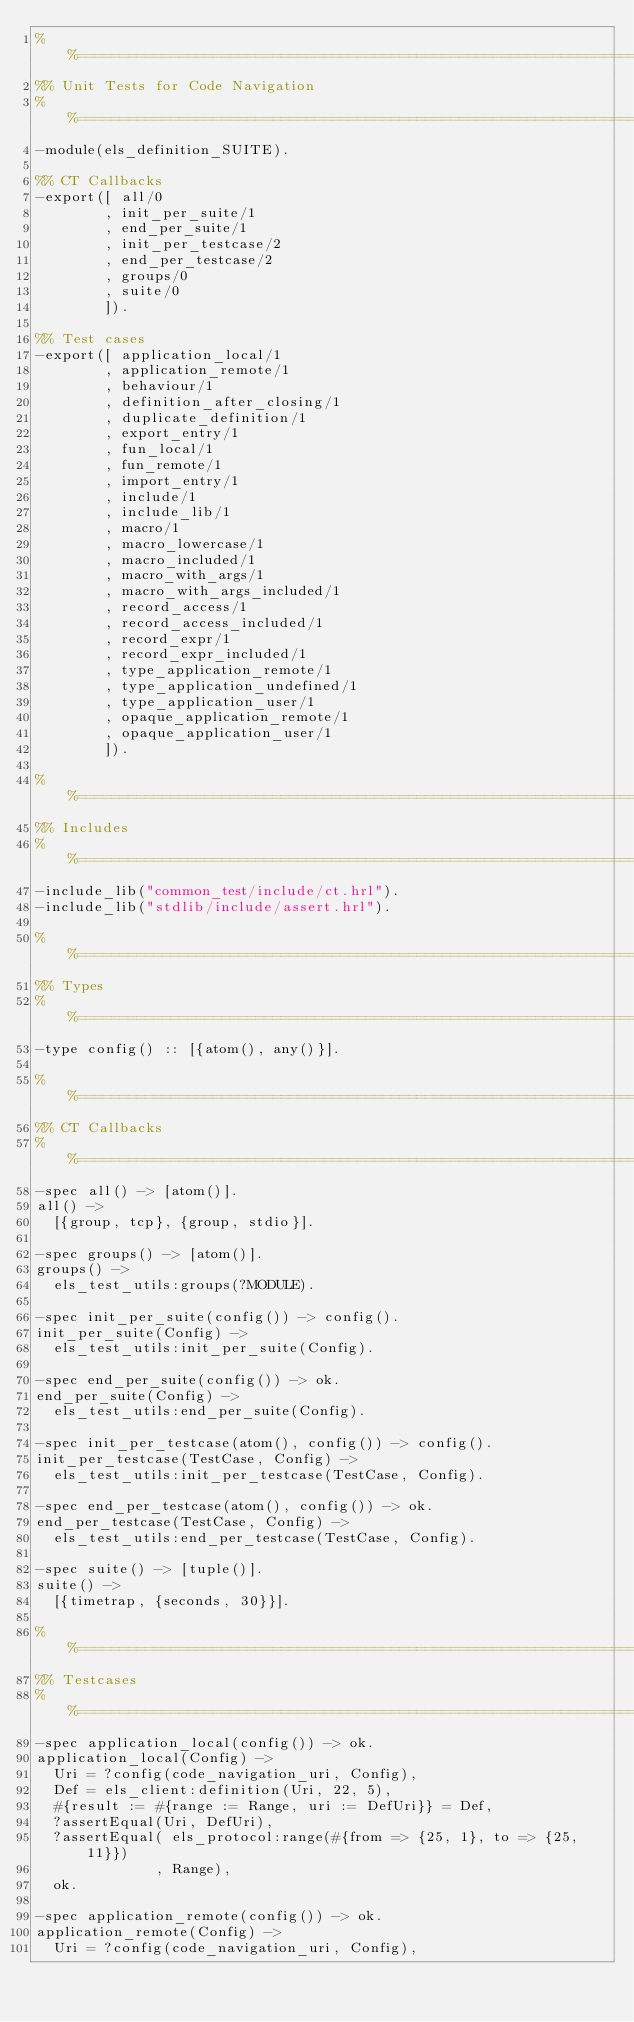Convert code to text. <code><loc_0><loc_0><loc_500><loc_500><_Erlang_>%%==============================================================================
%% Unit Tests for Code Navigation
%%==============================================================================
-module(els_definition_SUITE).

%% CT Callbacks
-export([ all/0
        , init_per_suite/1
        , end_per_suite/1
        , init_per_testcase/2
        , end_per_testcase/2
        , groups/0
        , suite/0
        ]).

%% Test cases
-export([ application_local/1
        , application_remote/1
        , behaviour/1
        , definition_after_closing/1
        , duplicate_definition/1
        , export_entry/1
        , fun_local/1
        , fun_remote/1
        , import_entry/1
        , include/1
        , include_lib/1
        , macro/1
        , macro_lowercase/1
        , macro_included/1
        , macro_with_args/1
        , macro_with_args_included/1
        , record_access/1
        , record_access_included/1
        , record_expr/1
        , record_expr_included/1
        , type_application_remote/1
        , type_application_undefined/1
        , type_application_user/1
        , opaque_application_remote/1
        , opaque_application_user/1
        ]).

%%==============================================================================
%% Includes
%%==============================================================================
-include_lib("common_test/include/ct.hrl").
-include_lib("stdlib/include/assert.hrl").

%%==============================================================================
%% Types
%%==============================================================================
-type config() :: [{atom(), any()}].

%%==============================================================================
%% CT Callbacks
%%==============================================================================
-spec all() -> [atom()].
all() ->
  [{group, tcp}, {group, stdio}].

-spec groups() -> [atom()].
groups() ->
  els_test_utils:groups(?MODULE).

-spec init_per_suite(config()) -> config().
init_per_suite(Config) ->
  els_test_utils:init_per_suite(Config).

-spec end_per_suite(config()) -> ok.
end_per_suite(Config) ->
  els_test_utils:end_per_suite(Config).

-spec init_per_testcase(atom(), config()) -> config().
init_per_testcase(TestCase, Config) ->
  els_test_utils:init_per_testcase(TestCase, Config).

-spec end_per_testcase(atom(), config()) -> ok.
end_per_testcase(TestCase, Config) ->
  els_test_utils:end_per_testcase(TestCase, Config).

-spec suite() -> [tuple()].
suite() ->
  [{timetrap, {seconds, 30}}].

%%==============================================================================
%% Testcases
%%==============================================================================
-spec application_local(config()) -> ok.
application_local(Config) ->
  Uri = ?config(code_navigation_uri, Config),
  Def = els_client:definition(Uri, 22, 5),
  #{result := #{range := Range, uri := DefUri}} = Def,
  ?assertEqual(Uri, DefUri),
  ?assertEqual( els_protocol:range(#{from => {25, 1}, to => {25, 11}})
              , Range),
  ok.

-spec application_remote(config()) -> ok.
application_remote(Config) ->
  Uri = ?config(code_navigation_uri, Config),</code> 